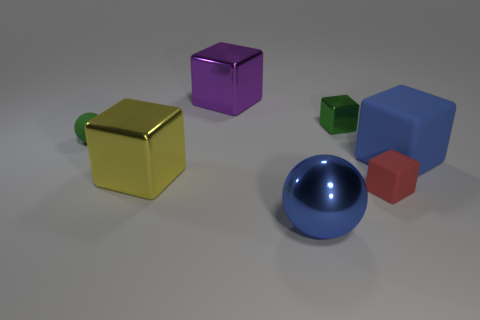There is a green object that is the same shape as the big blue metallic object; what is its material?
Your answer should be very brief. Rubber. There is a object that is both to the right of the blue sphere and on the left side of the tiny red matte object; what color is it?
Your response must be concise. Green. There is a large cube on the right side of the ball that is in front of the yellow metallic block; are there any big yellow things in front of it?
Make the answer very short. Yes. How many objects are either large purple cubes or red matte cubes?
Make the answer very short. 2. Is the material of the large blue cube the same as the ball to the right of the purple object?
Your answer should be compact. No. Is there any other thing that has the same color as the large matte object?
Give a very brief answer. Yes. How many objects are either green things to the right of the green rubber object or large blocks in front of the small green matte sphere?
Your answer should be compact. 3. There is a metal thing that is right of the purple metal block and in front of the small ball; what shape is it?
Offer a very short reply. Sphere. What number of tiny matte things are right of the small green object to the right of the large yellow block?
Provide a short and direct response. 1. Is there any other thing that is the same material as the big yellow block?
Your answer should be compact. Yes. 